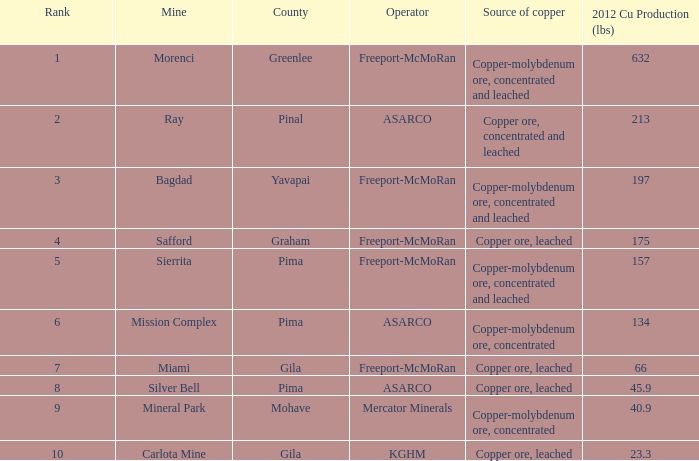Which operator has a rank of 7? Freeport-McMoRan. 